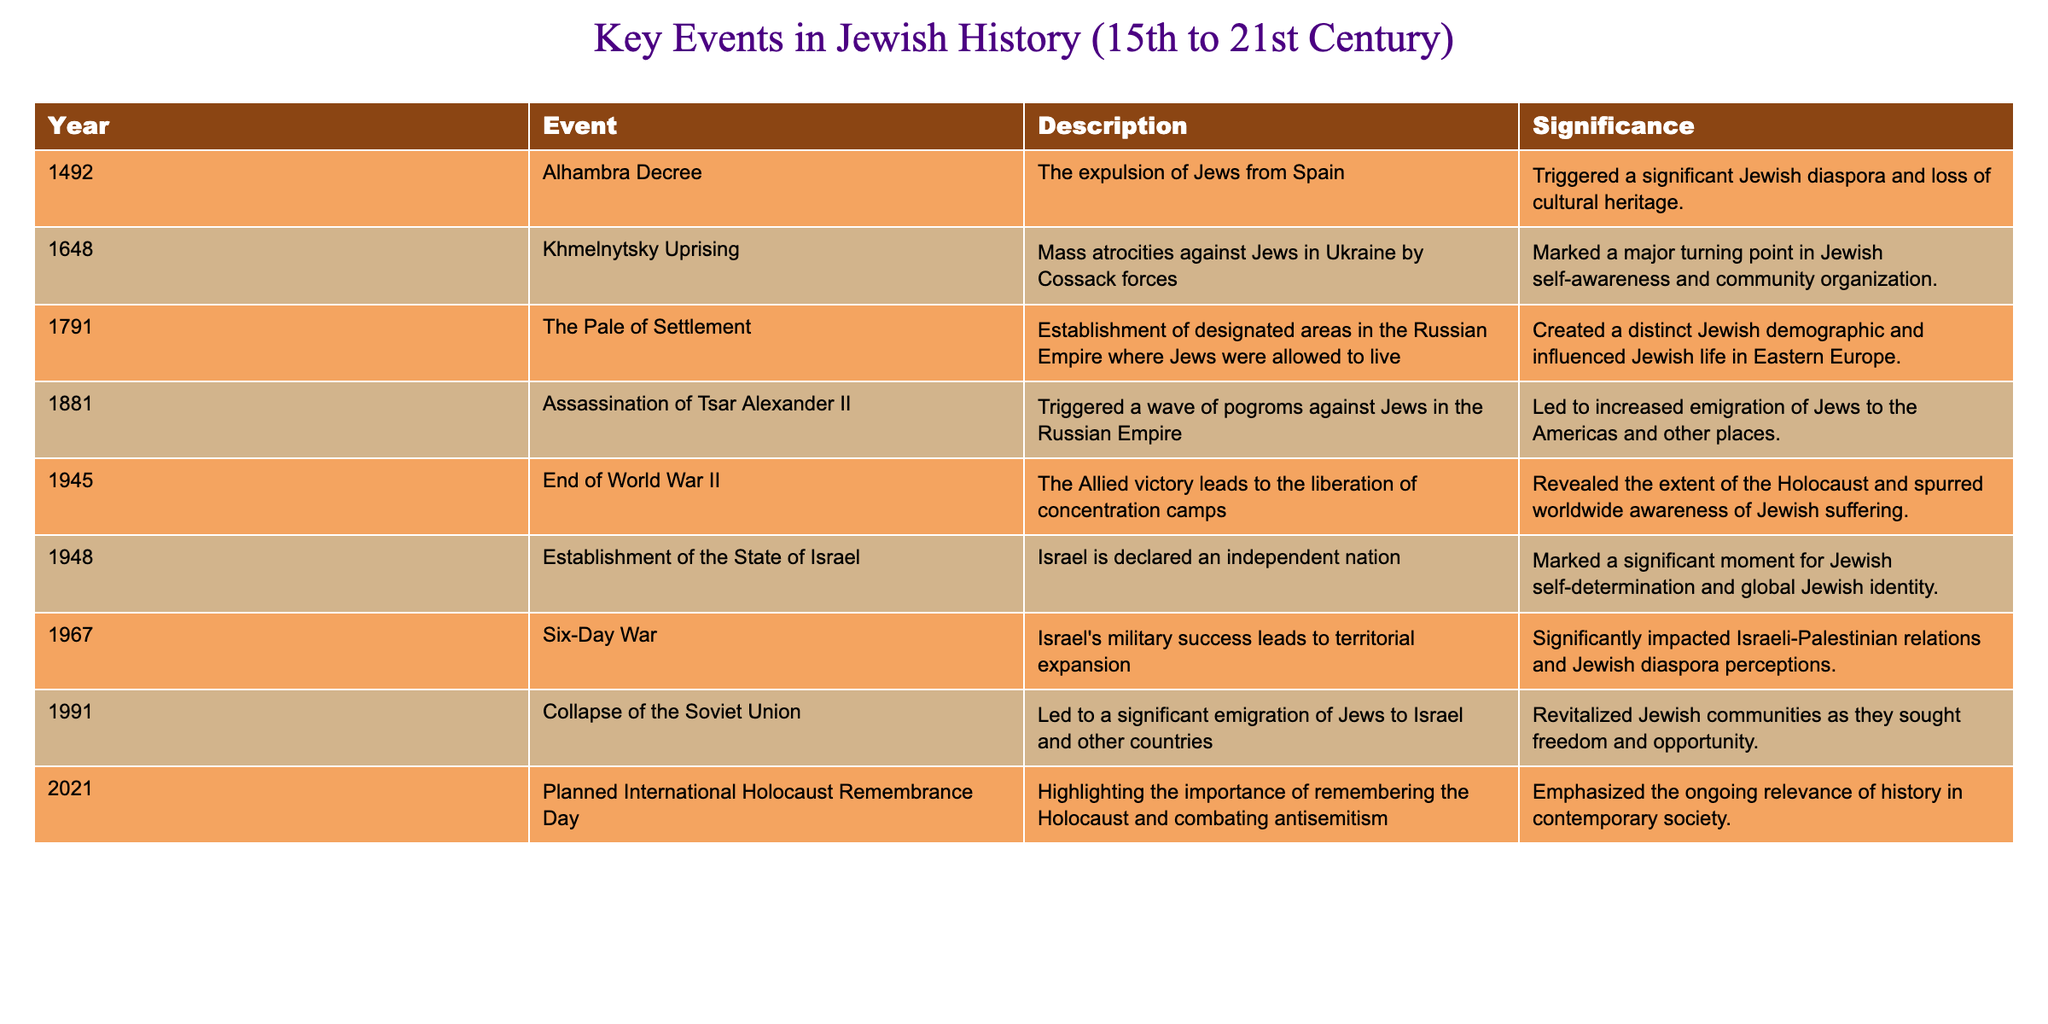What year did the Alhambra Decree take place? The Alhambra Decree is listed in the table under the year column, indicating that it occurred in 1492.
Answer: 1492 What was one significant consequence of the Khmelnytsky Uprising? The table describes the Khmelnytsky Uprising's significance as marking a major turning point in Jewish self-awareness and community organization.
Answer: Major turning point in Jewish self-awareness In what year was the State of Israel established? The table clearly shows that Israel was declared an independent nation in 1948.
Answer: 1948 Was the end of World War II significant for the Jewish community? According to the table, the end of World War II revealed the extent of the Holocaust and spurred worldwide awareness of Jewish suffering, indicating that it was indeed significant.
Answer: Yes How many key events listed occurred in the 20th century? The table contains events for the years 1945, 1948, 1967, and 1991, totaling four events in the 20th century.
Answer: 4 What is the difference in years between the establishment of the State of Israel and the end of World War II? The State of Israel was established in 1948 and World War II ended in 1945. The difference can be calculated as 1948 - 1945 = 3 years.
Answer: 3 years Identify the earliest event listed in the table and its significance. The earliest event is the Alhambra Decree in 1492, which is significant as it triggered a significant Jewish diaspora and loss of cultural heritage.
Answer: Alhambra Decree Which event led to a wave of pogroms against Jews? The assassination of Tsar Alexander II in 1881 triggered a wave of pogroms against Jews in the Russian Empire, as noted in the table.
Answer: Assassination of Tsar Alexander II What was the significance of the Collapse of the Soviet Union for Jewish communities? The collapse led to significant emigration of Jews to Israel and other countries and revitalized Jewish communities, indicating its importance in their history.
Answer: Revitalized Jewish communities 